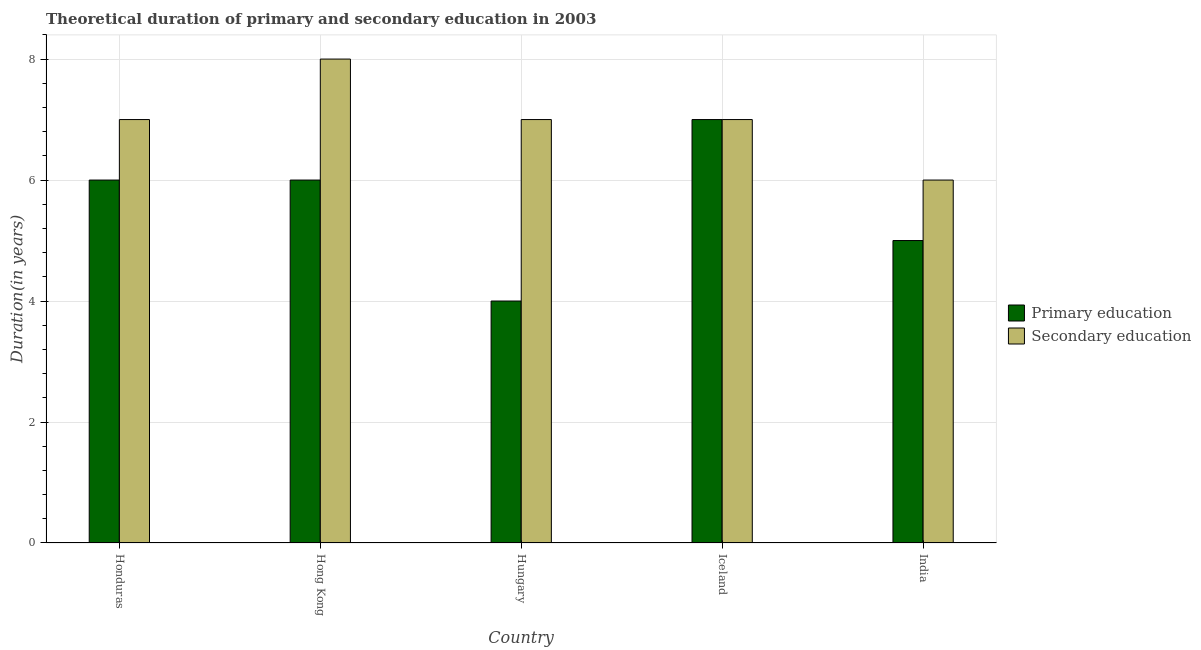How many different coloured bars are there?
Provide a short and direct response. 2. Are the number of bars on each tick of the X-axis equal?
Give a very brief answer. Yes. How many bars are there on the 1st tick from the right?
Keep it short and to the point. 2. What is the label of the 3rd group of bars from the left?
Keep it short and to the point. Hungary. In how many cases, is the number of bars for a given country not equal to the number of legend labels?
Provide a succinct answer. 0. Across all countries, what is the maximum duration of primary education?
Offer a terse response. 7. In which country was the duration of secondary education maximum?
Provide a short and direct response. Hong Kong. In which country was the duration of primary education minimum?
Offer a very short reply. Hungary. What is the total duration of secondary education in the graph?
Provide a short and direct response. 35. What is the difference between the duration of primary education in Hungary and that in India?
Provide a succinct answer. -1. What is the difference between the duration of primary education in Hungary and the duration of secondary education in India?
Ensure brevity in your answer.  -2. What is the difference between the duration of secondary education and duration of primary education in Honduras?
Provide a succinct answer. 1. Is the duration of secondary education in Hungary less than that in Iceland?
Offer a terse response. No. Is the difference between the duration of primary education in Honduras and Iceland greater than the difference between the duration of secondary education in Honduras and Iceland?
Offer a very short reply. No. What is the difference between the highest and the lowest duration of secondary education?
Give a very brief answer. 2. In how many countries, is the duration of secondary education greater than the average duration of secondary education taken over all countries?
Provide a succinct answer. 1. What does the 2nd bar from the left in India represents?
Give a very brief answer. Secondary education. What does the 1st bar from the right in Iceland represents?
Keep it short and to the point. Secondary education. What is the difference between two consecutive major ticks on the Y-axis?
Your answer should be very brief. 2. Does the graph contain any zero values?
Provide a succinct answer. No. Where does the legend appear in the graph?
Your response must be concise. Center right. How are the legend labels stacked?
Keep it short and to the point. Vertical. What is the title of the graph?
Keep it short and to the point. Theoretical duration of primary and secondary education in 2003. Does "Services" appear as one of the legend labels in the graph?
Make the answer very short. No. What is the label or title of the Y-axis?
Give a very brief answer. Duration(in years). What is the Duration(in years) of Secondary education in Honduras?
Give a very brief answer. 7. What is the Duration(in years) of Secondary education in Hungary?
Provide a short and direct response. 7. What is the Duration(in years) of Primary education in Iceland?
Your answer should be compact. 7. What is the Duration(in years) in Secondary education in Iceland?
Give a very brief answer. 7. Across all countries, what is the maximum Duration(in years) in Primary education?
Your answer should be compact. 7. Across all countries, what is the maximum Duration(in years) in Secondary education?
Your answer should be compact. 8. Across all countries, what is the minimum Duration(in years) in Primary education?
Offer a very short reply. 4. Across all countries, what is the minimum Duration(in years) in Secondary education?
Give a very brief answer. 6. What is the total Duration(in years) in Secondary education in the graph?
Give a very brief answer. 35. What is the difference between the Duration(in years) in Secondary education in Honduras and that in Hong Kong?
Give a very brief answer. -1. What is the difference between the Duration(in years) of Primary education in Honduras and that in Hungary?
Offer a very short reply. 2. What is the difference between the Duration(in years) in Primary education in Honduras and that in Iceland?
Give a very brief answer. -1. What is the difference between the Duration(in years) of Secondary education in Hong Kong and that in Iceland?
Offer a terse response. 1. What is the difference between the Duration(in years) of Secondary education in Hong Kong and that in India?
Your response must be concise. 2. What is the difference between the Duration(in years) of Primary education in Hungary and that in India?
Keep it short and to the point. -1. What is the difference between the Duration(in years) of Secondary education in Hungary and that in India?
Ensure brevity in your answer.  1. What is the difference between the Duration(in years) in Secondary education in Iceland and that in India?
Offer a terse response. 1. What is the difference between the Duration(in years) of Primary education in Honduras and the Duration(in years) of Secondary education in Hungary?
Ensure brevity in your answer.  -1. What is the difference between the Duration(in years) in Primary education in Honduras and the Duration(in years) in Secondary education in Iceland?
Ensure brevity in your answer.  -1. What is the difference between the Duration(in years) of Primary education in Hungary and the Duration(in years) of Secondary education in Iceland?
Offer a very short reply. -3. What is the difference between the Duration(in years) in Primary education in Iceland and the Duration(in years) in Secondary education in India?
Make the answer very short. 1. What is the difference between the Duration(in years) in Primary education and Duration(in years) in Secondary education in Honduras?
Your answer should be compact. -1. What is the ratio of the Duration(in years) of Secondary education in Honduras to that in Hong Kong?
Provide a succinct answer. 0.88. What is the ratio of the Duration(in years) in Primary education in Honduras to that in Hungary?
Your answer should be very brief. 1.5. What is the ratio of the Duration(in years) of Primary education in Honduras to that in Iceland?
Your answer should be compact. 0.86. What is the ratio of the Duration(in years) of Secondary education in Honduras to that in Iceland?
Offer a very short reply. 1. What is the ratio of the Duration(in years) in Primary education in Honduras to that in India?
Offer a terse response. 1.2. What is the ratio of the Duration(in years) in Primary education in Hong Kong to that in Hungary?
Ensure brevity in your answer.  1.5. What is the ratio of the Duration(in years) of Secondary education in Hong Kong to that in Hungary?
Keep it short and to the point. 1.14. What is the ratio of the Duration(in years) of Primary education in Hong Kong to that in Iceland?
Your answer should be compact. 0.86. What is the ratio of the Duration(in years) of Secondary education in Hong Kong to that in Iceland?
Provide a succinct answer. 1.14. What is the ratio of the Duration(in years) in Secondary education in Hong Kong to that in India?
Ensure brevity in your answer.  1.33. What is the ratio of the Duration(in years) in Primary education in Hungary to that in Iceland?
Make the answer very short. 0.57. What is the ratio of the Duration(in years) in Secondary education in Hungary to that in India?
Offer a terse response. 1.17. What is the ratio of the Duration(in years) in Primary education in Iceland to that in India?
Offer a very short reply. 1.4. What is the difference between the highest and the second highest Duration(in years) in Primary education?
Offer a very short reply. 1. What is the difference between the highest and the second highest Duration(in years) of Secondary education?
Keep it short and to the point. 1. 